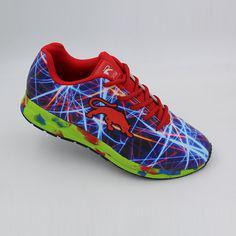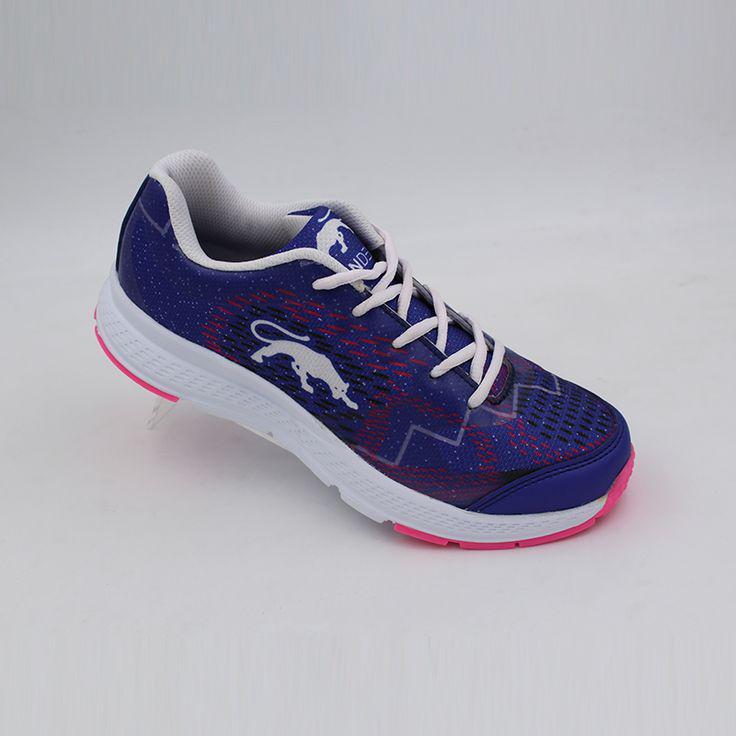The first image is the image on the left, the second image is the image on the right. Considering the images on both sides, is "Right image contains one shoe tilted and facing rightward, with a cat silhouette somewhere on it." valid? Answer yes or no. Yes. The first image is the image on the left, the second image is the image on the right. For the images displayed, is the sentence "The toe of the shoe in the image on the right is pointed to the left." factually correct? Answer yes or no. No. 